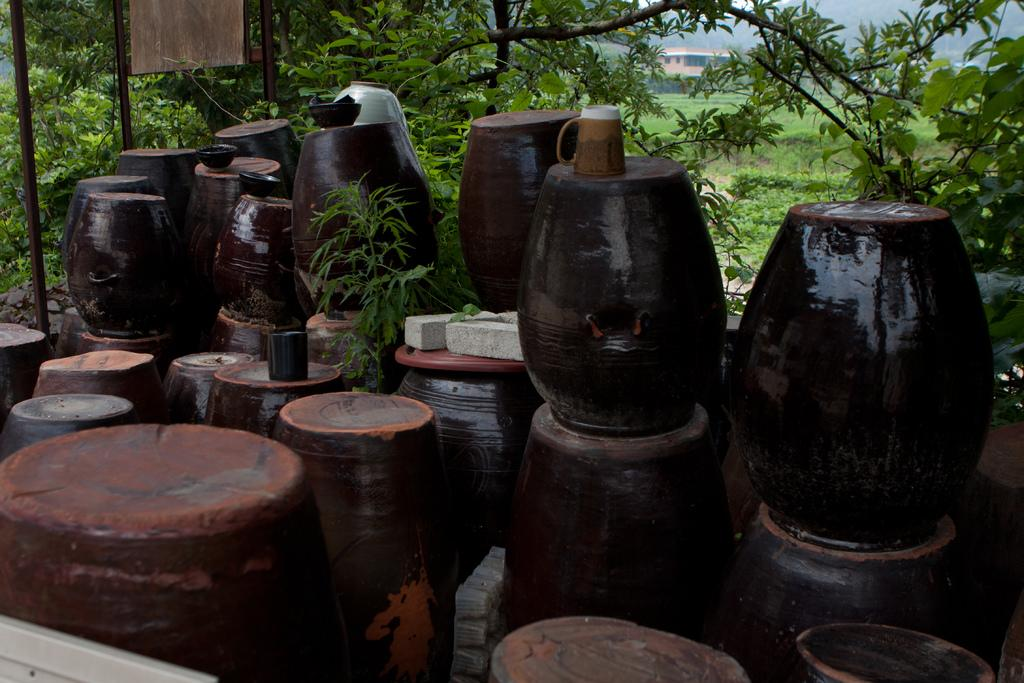What type of objects can be seen in the image? There are pots, a glass object, and plants in the image. What else is present in the image? There are trees in the image. What can be seen in the background of the image? There is a building in the background of the image. What type of pain is the person experiencing in the image? There is no person present in the image, and therefore no indication of any pain being experienced. 